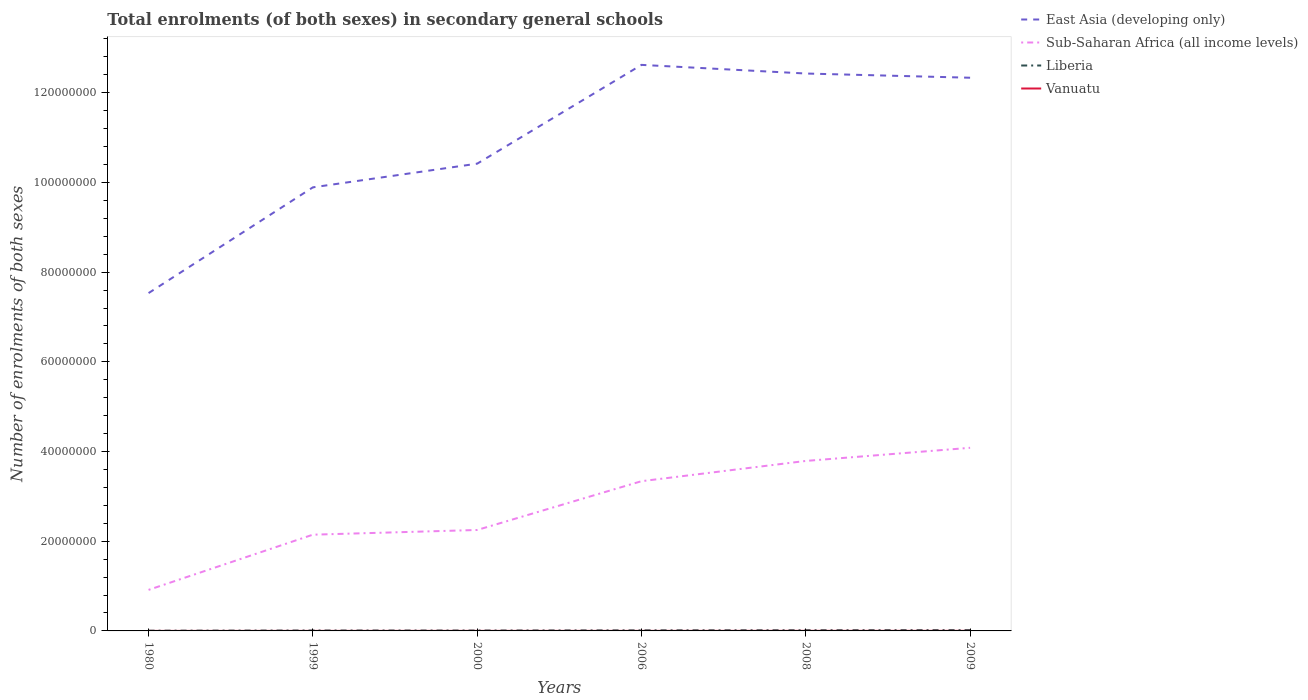Does the line corresponding to East Asia (developing only) intersect with the line corresponding to Liberia?
Your response must be concise. No. Across all years, what is the maximum number of enrolments in secondary schools in Liberia?
Provide a short and direct response. 5.17e+04. What is the total number of enrolments in secondary schools in East Asia (developing only) in the graph?
Keep it short and to the point. -5.28e+06. What is the difference between the highest and the second highest number of enrolments in secondary schools in Liberia?
Ensure brevity in your answer.  1.31e+05. What is the difference between the highest and the lowest number of enrolments in secondary schools in Sub-Saharan Africa (all income levels)?
Provide a short and direct response. 3. Is the number of enrolments in secondary schools in Sub-Saharan Africa (all income levels) strictly greater than the number of enrolments in secondary schools in East Asia (developing only) over the years?
Make the answer very short. Yes. How many lines are there?
Keep it short and to the point. 4. How many years are there in the graph?
Your response must be concise. 6. What is the difference between two consecutive major ticks on the Y-axis?
Ensure brevity in your answer.  2.00e+07. Are the values on the major ticks of Y-axis written in scientific E-notation?
Offer a terse response. No. Does the graph contain grids?
Your answer should be compact. No. How many legend labels are there?
Your response must be concise. 4. What is the title of the graph?
Provide a short and direct response. Total enrolments (of both sexes) in secondary general schools. Does "North America" appear as one of the legend labels in the graph?
Offer a terse response. No. What is the label or title of the X-axis?
Your answer should be compact. Years. What is the label or title of the Y-axis?
Your answer should be compact. Number of enrolments of both sexes. What is the Number of enrolments of both sexes of East Asia (developing only) in 1980?
Give a very brief answer. 7.53e+07. What is the Number of enrolments of both sexes in Sub-Saharan Africa (all income levels) in 1980?
Offer a very short reply. 9.15e+06. What is the Number of enrolments of both sexes of Liberia in 1980?
Your answer should be very brief. 5.17e+04. What is the Number of enrolments of both sexes in Vanuatu in 1980?
Your response must be concise. 1970. What is the Number of enrolments of both sexes in East Asia (developing only) in 1999?
Offer a very short reply. 9.89e+07. What is the Number of enrolments of both sexes in Sub-Saharan Africa (all income levels) in 1999?
Make the answer very short. 2.15e+07. What is the Number of enrolments of both sexes in Liberia in 1999?
Your answer should be compact. 9.41e+04. What is the Number of enrolments of both sexes of Vanuatu in 1999?
Your answer should be very brief. 8056. What is the Number of enrolments of both sexes in East Asia (developing only) in 2000?
Keep it short and to the point. 1.04e+08. What is the Number of enrolments of both sexes of Sub-Saharan Africa (all income levels) in 2000?
Provide a succinct answer. 2.25e+07. What is the Number of enrolments of both sexes of Liberia in 2000?
Your answer should be compact. 9.04e+04. What is the Number of enrolments of both sexes of Vanuatu in 2000?
Your response must be concise. 8580. What is the Number of enrolments of both sexes in East Asia (developing only) in 2006?
Offer a very short reply. 1.26e+08. What is the Number of enrolments of both sexes in Sub-Saharan Africa (all income levels) in 2006?
Your answer should be compact. 3.34e+07. What is the Number of enrolments of both sexes of Liberia in 2006?
Offer a terse response. 1.32e+05. What is the Number of enrolments of both sexes of Vanuatu in 2006?
Ensure brevity in your answer.  9564. What is the Number of enrolments of both sexes in East Asia (developing only) in 2008?
Offer a very short reply. 1.24e+08. What is the Number of enrolments of both sexes in Sub-Saharan Africa (all income levels) in 2008?
Your answer should be compact. 3.79e+07. What is the Number of enrolments of both sexes of Liberia in 2008?
Ensure brevity in your answer.  1.58e+05. What is the Number of enrolments of both sexes of Vanuatu in 2008?
Offer a terse response. 1.67e+04. What is the Number of enrolments of both sexes in East Asia (developing only) in 2009?
Give a very brief answer. 1.23e+08. What is the Number of enrolments of both sexes of Sub-Saharan Africa (all income levels) in 2009?
Ensure brevity in your answer.  4.08e+07. What is the Number of enrolments of both sexes of Liberia in 2009?
Your response must be concise. 1.83e+05. What is the Number of enrolments of both sexes of Vanuatu in 2009?
Provide a succinct answer. 1.79e+04. Across all years, what is the maximum Number of enrolments of both sexes in East Asia (developing only)?
Provide a succinct answer. 1.26e+08. Across all years, what is the maximum Number of enrolments of both sexes of Sub-Saharan Africa (all income levels)?
Your response must be concise. 4.08e+07. Across all years, what is the maximum Number of enrolments of both sexes of Liberia?
Offer a terse response. 1.83e+05. Across all years, what is the maximum Number of enrolments of both sexes of Vanuatu?
Your answer should be very brief. 1.79e+04. Across all years, what is the minimum Number of enrolments of both sexes of East Asia (developing only)?
Ensure brevity in your answer.  7.53e+07. Across all years, what is the minimum Number of enrolments of both sexes in Sub-Saharan Africa (all income levels)?
Make the answer very short. 9.15e+06. Across all years, what is the minimum Number of enrolments of both sexes of Liberia?
Offer a terse response. 5.17e+04. Across all years, what is the minimum Number of enrolments of both sexes in Vanuatu?
Give a very brief answer. 1970. What is the total Number of enrolments of both sexes of East Asia (developing only) in the graph?
Provide a succinct answer. 6.52e+08. What is the total Number of enrolments of both sexes in Sub-Saharan Africa (all income levels) in the graph?
Offer a terse response. 1.65e+08. What is the total Number of enrolments of both sexes of Liberia in the graph?
Your answer should be very brief. 7.10e+05. What is the total Number of enrolments of both sexes in Vanuatu in the graph?
Provide a succinct answer. 6.28e+04. What is the difference between the Number of enrolments of both sexes in East Asia (developing only) in 1980 and that in 1999?
Make the answer very short. -2.36e+07. What is the difference between the Number of enrolments of both sexes of Sub-Saharan Africa (all income levels) in 1980 and that in 1999?
Your response must be concise. -1.23e+07. What is the difference between the Number of enrolments of both sexes in Liberia in 1980 and that in 1999?
Keep it short and to the point. -4.25e+04. What is the difference between the Number of enrolments of both sexes in Vanuatu in 1980 and that in 1999?
Your response must be concise. -6086. What is the difference between the Number of enrolments of both sexes in East Asia (developing only) in 1980 and that in 2000?
Your response must be concise. -2.89e+07. What is the difference between the Number of enrolments of both sexes in Sub-Saharan Africa (all income levels) in 1980 and that in 2000?
Offer a very short reply. -1.34e+07. What is the difference between the Number of enrolments of both sexes of Liberia in 1980 and that in 2000?
Offer a terse response. -3.88e+04. What is the difference between the Number of enrolments of both sexes of Vanuatu in 1980 and that in 2000?
Your answer should be very brief. -6610. What is the difference between the Number of enrolments of both sexes of East Asia (developing only) in 1980 and that in 2006?
Give a very brief answer. -5.09e+07. What is the difference between the Number of enrolments of both sexes of Sub-Saharan Africa (all income levels) in 1980 and that in 2006?
Offer a very short reply. -2.42e+07. What is the difference between the Number of enrolments of both sexes of Liberia in 1980 and that in 2006?
Your answer should be very brief. -8.06e+04. What is the difference between the Number of enrolments of both sexes of Vanuatu in 1980 and that in 2006?
Make the answer very short. -7594. What is the difference between the Number of enrolments of both sexes in East Asia (developing only) in 1980 and that in 2008?
Offer a terse response. -4.90e+07. What is the difference between the Number of enrolments of both sexes of Sub-Saharan Africa (all income levels) in 1980 and that in 2008?
Provide a short and direct response. -2.88e+07. What is the difference between the Number of enrolments of both sexes of Liberia in 1980 and that in 2008?
Keep it short and to the point. -1.07e+05. What is the difference between the Number of enrolments of both sexes of Vanuatu in 1980 and that in 2008?
Your response must be concise. -1.48e+04. What is the difference between the Number of enrolments of both sexes of East Asia (developing only) in 1980 and that in 2009?
Provide a succinct answer. -4.80e+07. What is the difference between the Number of enrolments of both sexes in Sub-Saharan Africa (all income levels) in 1980 and that in 2009?
Provide a short and direct response. -3.17e+07. What is the difference between the Number of enrolments of both sexes in Liberia in 1980 and that in 2009?
Your answer should be compact. -1.31e+05. What is the difference between the Number of enrolments of both sexes of Vanuatu in 1980 and that in 2009?
Offer a terse response. -1.59e+04. What is the difference between the Number of enrolments of both sexes in East Asia (developing only) in 1999 and that in 2000?
Ensure brevity in your answer.  -5.28e+06. What is the difference between the Number of enrolments of both sexes in Sub-Saharan Africa (all income levels) in 1999 and that in 2000?
Your answer should be compact. -1.05e+06. What is the difference between the Number of enrolments of both sexes in Liberia in 1999 and that in 2000?
Your answer should be very brief. 3684. What is the difference between the Number of enrolments of both sexes of Vanuatu in 1999 and that in 2000?
Provide a succinct answer. -524. What is the difference between the Number of enrolments of both sexes of East Asia (developing only) in 1999 and that in 2006?
Ensure brevity in your answer.  -2.73e+07. What is the difference between the Number of enrolments of both sexes of Sub-Saharan Africa (all income levels) in 1999 and that in 2006?
Provide a short and direct response. -1.19e+07. What is the difference between the Number of enrolments of both sexes of Liberia in 1999 and that in 2006?
Your response must be concise. -3.81e+04. What is the difference between the Number of enrolments of both sexes of Vanuatu in 1999 and that in 2006?
Your response must be concise. -1508. What is the difference between the Number of enrolments of both sexes of East Asia (developing only) in 1999 and that in 2008?
Keep it short and to the point. -2.54e+07. What is the difference between the Number of enrolments of both sexes in Sub-Saharan Africa (all income levels) in 1999 and that in 2008?
Your answer should be compact. -1.64e+07. What is the difference between the Number of enrolments of both sexes of Liberia in 1999 and that in 2008?
Provide a short and direct response. -6.41e+04. What is the difference between the Number of enrolments of both sexes in Vanuatu in 1999 and that in 2008?
Ensure brevity in your answer.  -8678. What is the difference between the Number of enrolments of both sexes in East Asia (developing only) in 1999 and that in 2009?
Provide a short and direct response. -2.44e+07. What is the difference between the Number of enrolments of both sexes of Sub-Saharan Africa (all income levels) in 1999 and that in 2009?
Provide a succinct answer. -1.94e+07. What is the difference between the Number of enrolments of both sexes in Liberia in 1999 and that in 2009?
Provide a short and direct response. -8.87e+04. What is the difference between the Number of enrolments of both sexes in Vanuatu in 1999 and that in 2009?
Provide a short and direct response. -9821. What is the difference between the Number of enrolments of both sexes of East Asia (developing only) in 2000 and that in 2006?
Your answer should be very brief. -2.20e+07. What is the difference between the Number of enrolments of both sexes of Sub-Saharan Africa (all income levels) in 2000 and that in 2006?
Provide a short and direct response. -1.09e+07. What is the difference between the Number of enrolments of both sexes in Liberia in 2000 and that in 2006?
Provide a short and direct response. -4.18e+04. What is the difference between the Number of enrolments of both sexes of Vanuatu in 2000 and that in 2006?
Offer a very short reply. -984. What is the difference between the Number of enrolments of both sexes of East Asia (developing only) in 2000 and that in 2008?
Provide a short and direct response. -2.01e+07. What is the difference between the Number of enrolments of both sexes of Sub-Saharan Africa (all income levels) in 2000 and that in 2008?
Give a very brief answer. -1.54e+07. What is the difference between the Number of enrolments of both sexes of Liberia in 2000 and that in 2008?
Offer a terse response. -6.78e+04. What is the difference between the Number of enrolments of both sexes in Vanuatu in 2000 and that in 2008?
Keep it short and to the point. -8154. What is the difference between the Number of enrolments of both sexes in East Asia (developing only) in 2000 and that in 2009?
Provide a short and direct response. -1.92e+07. What is the difference between the Number of enrolments of both sexes of Sub-Saharan Africa (all income levels) in 2000 and that in 2009?
Provide a succinct answer. -1.83e+07. What is the difference between the Number of enrolments of both sexes of Liberia in 2000 and that in 2009?
Make the answer very short. -9.24e+04. What is the difference between the Number of enrolments of both sexes of Vanuatu in 2000 and that in 2009?
Offer a very short reply. -9297. What is the difference between the Number of enrolments of both sexes in East Asia (developing only) in 2006 and that in 2008?
Ensure brevity in your answer.  1.93e+06. What is the difference between the Number of enrolments of both sexes of Sub-Saharan Africa (all income levels) in 2006 and that in 2008?
Give a very brief answer. -4.52e+06. What is the difference between the Number of enrolments of both sexes of Liberia in 2006 and that in 2008?
Provide a short and direct response. -2.60e+04. What is the difference between the Number of enrolments of both sexes in Vanuatu in 2006 and that in 2008?
Your answer should be very brief. -7170. What is the difference between the Number of enrolments of both sexes of East Asia (developing only) in 2006 and that in 2009?
Your answer should be compact. 2.87e+06. What is the difference between the Number of enrolments of both sexes in Sub-Saharan Africa (all income levels) in 2006 and that in 2009?
Give a very brief answer. -7.44e+06. What is the difference between the Number of enrolments of both sexes in Liberia in 2006 and that in 2009?
Provide a short and direct response. -5.06e+04. What is the difference between the Number of enrolments of both sexes of Vanuatu in 2006 and that in 2009?
Ensure brevity in your answer.  -8313. What is the difference between the Number of enrolments of both sexes in East Asia (developing only) in 2008 and that in 2009?
Offer a very short reply. 9.38e+05. What is the difference between the Number of enrolments of both sexes of Sub-Saharan Africa (all income levels) in 2008 and that in 2009?
Ensure brevity in your answer.  -2.93e+06. What is the difference between the Number of enrolments of both sexes of Liberia in 2008 and that in 2009?
Offer a very short reply. -2.46e+04. What is the difference between the Number of enrolments of both sexes in Vanuatu in 2008 and that in 2009?
Give a very brief answer. -1143. What is the difference between the Number of enrolments of both sexes in East Asia (developing only) in 1980 and the Number of enrolments of both sexes in Sub-Saharan Africa (all income levels) in 1999?
Offer a very short reply. 5.39e+07. What is the difference between the Number of enrolments of both sexes in East Asia (developing only) in 1980 and the Number of enrolments of both sexes in Liberia in 1999?
Offer a very short reply. 7.52e+07. What is the difference between the Number of enrolments of both sexes of East Asia (developing only) in 1980 and the Number of enrolments of both sexes of Vanuatu in 1999?
Make the answer very short. 7.53e+07. What is the difference between the Number of enrolments of both sexes of Sub-Saharan Africa (all income levels) in 1980 and the Number of enrolments of both sexes of Liberia in 1999?
Keep it short and to the point. 9.06e+06. What is the difference between the Number of enrolments of both sexes in Sub-Saharan Africa (all income levels) in 1980 and the Number of enrolments of both sexes in Vanuatu in 1999?
Your answer should be very brief. 9.14e+06. What is the difference between the Number of enrolments of both sexes of Liberia in 1980 and the Number of enrolments of both sexes of Vanuatu in 1999?
Offer a terse response. 4.36e+04. What is the difference between the Number of enrolments of both sexes of East Asia (developing only) in 1980 and the Number of enrolments of both sexes of Sub-Saharan Africa (all income levels) in 2000?
Give a very brief answer. 5.28e+07. What is the difference between the Number of enrolments of both sexes in East Asia (developing only) in 1980 and the Number of enrolments of both sexes in Liberia in 2000?
Offer a terse response. 7.52e+07. What is the difference between the Number of enrolments of both sexes in East Asia (developing only) in 1980 and the Number of enrolments of both sexes in Vanuatu in 2000?
Give a very brief answer. 7.53e+07. What is the difference between the Number of enrolments of both sexes in Sub-Saharan Africa (all income levels) in 1980 and the Number of enrolments of both sexes in Liberia in 2000?
Your answer should be compact. 9.06e+06. What is the difference between the Number of enrolments of both sexes of Sub-Saharan Africa (all income levels) in 1980 and the Number of enrolments of both sexes of Vanuatu in 2000?
Provide a short and direct response. 9.14e+06. What is the difference between the Number of enrolments of both sexes of Liberia in 1980 and the Number of enrolments of both sexes of Vanuatu in 2000?
Ensure brevity in your answer.  4.31e+04. What is the difference between the Number of enrolments of both sexes of East Asia (developing only) in 1980 and the Number of enrolments of both sexes of Sub-Saharan Africa (all income levels) in 2006?
Your response must be concise. 4.19e+07. What is the difference between the Number of enrolments of both sexes in East Asia (developing only) in 1980 and the Number of enrolments of both sexes in Liberia in 2006?
Keep it short and to the point. 7.52e+07. What is the difference between the Number of enrolments of both sexes of East Asia (developing only) in 1980 and the Number of enrolments of both sexes of Vanuatu in 2006?
Provide a succinct answer. 7.53e+07. What is the difference between the Number of enrolments of both sexes of Sub-Saharan Africa (all income levels) in 1980 and the Number of enrolments of both sexes of Liberia in 2006?
Offer a terse response. 9.02e+06. What is the difference between the Number of enrolments of both sexes of Sub-Saharan Africa (all income levels) in 1980 and the Number of enrolments of both sexes of Vanuatu in 2006?
Your response must be concise. 9.14e+06. What is the difference between the Number of enrolments of both sexes of Liberia in 1980 and the Number of enrolments of both sexes of Vanuatu in 2006?
Ensure brevity in your answer.  4.21e+04. What is the difference between the Number of enrolments of both sexes in East Asia (developing only) in 1980 and the Number of enrolments of both sexes in Sub-Saharan Africa (all income levels) in 2008?
Your response must be concise. 3.74e+07. What is the difference between the Number of enrolments of both sexes in East Asia (developing only) in 1980 and the Number of enrolments of both sexes in Liberia in 2008?
Give a very brief answer. 7.52e+07. What is the difference between the Number of enrolments of both sexes of East Asia (developing only) in 1980 and the Number of enrolments of both sexes of Vanuatu in 2008?
Make the answer very short. 7.53e+07. What is the difference between the Number of enrolments of both sexes of Sub-Saharan Africa (all income levels) in 1980 and the Number of enrolments of both sexes of Liberia in 2008?
Your response must be concise. 8.99e+06. What is the difference between the Number of enrolments of both sexes of Sub-Saharan Africa (all income levels) in 1980 and the Number of enrolments of both sexes of Vanuatu in 2008?
Give a very brief answer. 9.13e+06. What is the difference between the Number of enrolments of both sexes of Liberia in 1980 and the Number of enrolments of both sexes of Vanuatu in 2008?
Your response must be concise. 3.49e+04. What is the difference between the Number of enrolments of both sexes of East Asia (developing only) in 1980 and the Number of enrolments of both sexes of Sub-Saharan Africa (all income levels) in 2009?
Offer a terse response. 3.45e+07. What is the difference between the Number of enrolments of both sexes of East Asia (developing only) in 1980 and the Number of enrolments of both sexes of Liberia in 2009?
Offer a very short reply. 7.51e+07. What is the difference between the Number of enrolments of both sexes in East Asia (developing only) in 1980 and the Number of enrolments of both sexes in Vanuatu in 2009?
Make the answer very short. 7.53e+07. What is the difference between the Number of enrolments of both sexes in Sub-Saharan Africa (all income levels) in 1980 and the Number of enrolments of both sexes in Liberia in 2009?
Provide a succinct answer. 8.97e+06. What is the difference between the Number of enrolments of both sexes in Sub-Saharan Africa (all income levels) in 1980 and the Number of enrolments of both sexes in Vanuatu in 2009?
Keep it short and to the point. 9.13e+06. What is the difference between the Number of enrolments of both sexes of Liberia in 1980 and the Number of enrolments of both sexes of Vanuatu in 2009?
Keep it short and to the point. 3.38e+04. What is the difference between the Number of enrolments of both sexes in East Asia (developing only) in 1999 and the Number of enrolments of both sexes in Sub-Saharan Africa (all income levels) in 2000?
Offer a terse response. 7.64e+07. What is the difference between the Number of enrolments of both sexes of East Asia (developing only) in 1999 and the Number of enrolments of both sexes of Liberia in 2000?
Provide a short and direct response. 9.88e+07. What is the difference between the Number of enrolments of both sexes of East Asia (developing only) in 1999 and the Number of enrolments of both sexes of Vanuatu in 2000?
Offer a very short reply. 9.89e+07. What is the difference between the Number of enrolments of both sexes in Sub-Saharan Africa (all income levels) in 1999 and the Number of enrolments of both sexes in Liberia in 2000?
Your response must be concise. 2.14e+07. What is the difference between the Number of enrolments of both sexes in Sub-Saharan Africa (all income levels) in 1999 and the Number of enrolments of both sexes in Vanuatu in 2000?
Offer a very short reply. 2.15e+07. What is the difference between the Number of enrolments of both sexes of Liberia in 1999 and the Number of enrolments of both sexes of Vanuatu in 2000?
Your answer should be very brief. 8.55e+04. What is the difference between the Number of enrolments of both sexes in East Asia (developing only) in 1999 and the Number of enrolments of both sexes in Sub-Saharan Africa (all income levels) in 2006?
Offer a terse response. 6.55e+07. What is the difference between the Number of enrolments of both sexes in East Asia (developing only) in 1999 and the Number of enrolments of both sexes in Liberia in 2006?
Make the answer very short. 9.88e+07. What is the difference between the Number of enrolments of both sexes of East Asia (developing only) in 1999 and the Number of enrolments of both sexes of Vanuatu in 2006?
Offer a terse response. 9.89e+07. What is the difference between the Number of enrolments of both sexes of Sub-Saharan Africa (all income levels) in 1999 and the Number of enrolments of both sexes of Liberia in 2006?
Provide a short and direct response. 2.13e+07. What is the difference between the Number of enrolments of both sexes of Sub-Saharan Africa (all income levels) in 1999 and the Number of enrolments of both sexes of Vanuatu in 2006?
Give a very brief answer. 2.14e+07. What is the difference between the Number of enrolments of both sexes in Liberia in 1999 and the Number of enrolments of both sexes in Vanuatu in 2006?
Keep it short and to the point. 8.46e+04. What is the difference between the Number of enrolments of both sexes in East Asia (developing only) in 1999 and the Number of enrolments of both sexes in Sub-Saharan Africa (all income levels) in 2008?
Give a very brief answer. 6.10e+07. What is the difference between the Number of enrolments of both sexes in East Asia (developing only) in 1999 and the Number of enrolments of both sexes in Liberia in 2008?
Ensure brevity in your answer.  9.87e+07. What is the difference between the Number of enrolments of both sexes of East Asia (developing only) in 1999 and the Number of enrolments of both sexes of Vanuatu in 2008?
Give a very brief answer. 9.89e+07. What is the difference between the Number of enrolments of both sexes in Sub-Saharan Africa (all income levels) in 1999 and the Number of enrolments of both sexes in Liberia in 2008?
Your answer should be compact. 2.13e+07. What is the difference between the Number of enrolments of both sexes of Sub-Saharan Africa (all income levels) in 1999 and the Number of enrolments of both sexes of Vanuatu in 2008?
Ensure brevity in your answer.  2.14e+07. What is the difference between the Number of enrolments of both sexes in Liberia in 1999 and the Number of enrolments of both sexes in Vanuatu in 2008?
Your response must be concise. 7.74e+04. What is the difference between the Number of enrolments of both sexes in East Asia (developing only) in 1999 and the Number of enrolments of both sexes in Sub-Saharan Africa (all income levels) in 2009?
Make the answer very short. 5.81e+07. What is the difference between the Number of enrolments of both sexes of East Asia (developing only) in 1999 and the Number of enrolments of both sexes of Liberia in 2009?
Provide a short and direct response. 9.87e+07. What is the difference between the Number of enrolments of both sexes of East Asia (developing only) in 1999 and the Number of enrolments of both sexes of Vanuatu in 2009?
Your answer should be compact. 9.89e+07. What is the difference between the Number of enrolments of both sexes of Sub-Saharan Africa (all income levels) in 1999 and the Number of enrolments of both sexes of Liberia in 2009?
Ensure brevity in your answer.  2.13e+07. What is the difference between the Number of enrolments of both sexes in Sub-Saharan Africa (all income levels) in 1999 and the Number of enrolments of both sexes in Vanuatu in 2009?
Your response must be concise. 2.14e+07. What is the difference between the Number of enrolments of both sexes in Liberia in 1999 and the Number of enrolments of both sexes in Vanuatu in 2009?
Keep it short and to the point. 7.62e+04. What is the difference between the Number of enrolments of both sexes of East Asia (developing only) in 2000 and the Number of enrolments of both sexes of Sub-Saharan Africa (all income levels) in 2006?
Ensure brevity in your answer.  7.08e+07. What is the difference between the Number of enrolments of both sexes in East Asia (developing only) in 2000 and the Number of enrolments of both sexes in Liberia in 2006?
Offer a very short reply. 1.04e+08. What is the difference between the Number of enrolments of both sexes in East Asia (developing only) in 2000 and the Number of enrolments of both sexes in Vanuatu in 2006?
Ensure brevity in your answer.  1.04e+08. What is the difference between the Number of enrolments of both sexes in Sub-Saharan Africa (all income levels) in 2000 and the Number of enrolments of both sexes in Liberia in 2006?
Offer a very short reply. 2.24e+07. What is the difference between the Number of enrolments of both sexes of Sub-Saharan Africa (all income levels) in 2000 and the Number of enrolments of both sexes of Vanuatu in 2006?
Provide a succinct answer. 2.25e+07. What is the difference between the Number of enrolments of both sexes in Liberia in 2000 and the Number of enrolments of both sexes in Vanuatu in 2006?
Your response must be concise. 8.09e+04. What is the difference between the Number of enrolments of both sexes in East Asia (developing only) in 2000 and the Number of enrolments of both sexes in Sub-Saharan Africa (all income levels) in 2008?
Provide a short and direct response. 6.63e+07. What is the difference between the Number of enrolments of both sexes in East Asia (developing only) in 2000 and the Number of enrolments of both sexes in Liberia in 2008?
Your answer should be compact. 1.04e+08. What is the difference between the Number of enrolments of both sexes in East Asia (developing only) in 2000 and the Number of enrolments of both sexes in Vanuatu in 2008?
Give a very brief answer. 1.04e+08. What is the difference between the Number of enrolments of both sexes in Sub-Saharan Africa (all income levels) in 2000 and the Number of enrolments of both sexes in Liberia in 2008?
Provide a short and direct response. 2.23e+07. What is the difference between the Number of enrolments of both sexes of Sub-Saharan Africa (all income levels) in 2000 and the Number of enrolments of both sexes of Vanuatu in 2008?
Provide a succinct answer. 2.25e+07. What is the difference between the Number of enrolments of both sexes in Liberia in 2000 and the Number of enrolments of both sexes in Vanuatu in 2008?
Your answer should be compact. 7.37e+04. What is the difference between the Number of enrolments of both sexes of East Asia (developing only) in 2000 and the Number of enrolments of both sexes of Sub-Saharan Africa (all income levels) in 2009?
Provide a succinct answer. 6.34e+07. What is the difference between the Number of enrolments of both sexes of East Asia (developing only) in 2000 and the Number of enrolments of both sexes of Liberia in 2009?
Your answer should be compact. 1.04e+08. What is the difference between the Number of enrolments of both sexes of East Asia (developing only) in 2000 and the Number of enrolments of both sexes of Vanuatu in 2009?
Your answer should be compact. 1.04e+08. What is the difference between the Number of enrolments of both sexes in Sub-Saharan Africa (all income levels) in 2000 and the Number of enrolments of both sexes in Liberia in 2009?
Give a very brief answer. 2.23e+07. What is the difference between the Number of enrolments of both sexes of Sub-Saharan Africa (all income levels) in 2000 and the Number of enrolments of both sexes of Vanuatu in 2009?
Keep it short and to the point. 2.25e+07. What is the difference between the Number of enrolments of both sexes of Liberia in 2000 and the Number of enrolments of both sexes of Vanuatu in 2009?
Your answer should be compact. 7.26e+04. What is the difference between the Number of enrolments of both sexes of East Asia (developing only) in 2006 and the Number of enrolments of both sexes of Sub-Saharan Africa (all income levels) in 2008?
Offer a terse response. 8.83e+07. What is the difference between the Number of enrolments of both sexes in East Asia (developing only) in 2006 and the Number of enrolments of both sexes in Liberia in 2008?
Your answer should be very brief. 1.26e+08. What is the difference between the Number of enrolments of both sexes in East Asia (developing only) in 2006 and the Number of enrolments of both sexes in Vanuatu in 2008?
Keep it short and to the point. 1.26e+08. What is the difference between the Number of enrolments of both sexes of Sub-Saharan Africa (all income levels) in 2006 and the Number of enrolments of both sexes of Liberia in 2008?
Offer a terse response. 3.32e+07. What is the difference between the Number of enrolments of both sexes of Sub-Saharan Africa (all income levels) in 2006 and the Number of enrolments of both sexes of Vanuatu in 2008?
Provide a succinct answer. 3.34e+07. What is the difference between the Number of enrolments of both sexes in Liberia in 2006 and the Number of enrolments of both sexes in Vanuatu in 2008?
Keep it short and to the point. 1.15e+05. What is the difference between the Number of enrolments of both sexes in East Asia (developing only) in 2006 and the Number of enrolments of both sexes in Sub-Saharan Africa (all income levels) in 2009?
Give a very brief answer. 8.54e+07. What is the difference between the Number of enrolments of both sexes in East Asia (developing only) in 2006 and the Number of enrolments of both sexes in Liberia in 2009?
Make the answer very short. 1.26e+08. What is the difference between the Number of enrolments of both sexes of East Asia (developing only) in 2006 and the Number of enrolments of both sexes of Vanuatu in 2009?
Provide a short and direct response. 1.26e+08. What is the difference between the Number of enrolments of both sexes of Sub-Saharan Africa (all income levels) in 2006 and the Number of enrolments of both sexes of Liberia in 2009?
Offer a terse response. 3.32e+07. What is the difference between the Number of enrolments of both sexes in Sub-Saharan Africa (all income levels) in 2006 and the Number of enrolments of both sexes in Vanuatu in 2009?
Your answer should be very brief. 3.34e+07. What is the difference between the Number of enrolments of both sexes in Liberia in 2006 and the Number of enrolments of both sexes in Vanuatu in 2009?
Your answer should be very brief. 1.14e+05. What is the difference between the Number of enrolments of both sexes of East Asia (developing only) in 2008 and the Number of enrolments of both sexes of Sub-Saharan Africa (all income levels) in 2009?
Keep it short and to the point. 8.35e+07. What is the difference between the Number of enrolments of both sexes of East Asia (developing only) in 2008 and the Number of enrolments of both sexes of Liberia in 2009?
Give a very brief answer. 1.24e+08. What is the difference between the Number of enrolments of both sexes of East Asia (developing only) in 2008 and the Number of enrolments of both sexes of Vanuatu in 2009?
Offer a very short reply. 1.24e+08. What is the difference between the Number of enrolments of both sexes of Sub-Saharan Africa (all income levels) in 2008 and the Number of enrolments of both sexes of Liberia in 2009?
Give a very brief answer. 3.77e+07. What is the difference between the Number of enrolments of both sexes of Sub-Saharan Africa (all income levels) in 2008 and the Number of enrolments of both sexes of Vanuatu in 2009?
Provide a succinct answer. 3.79e+07. What is the difference between the Number of enrolments of both sexes in Liberia in 2008 and the Number of enrolments of both sexes in Vanuatu in 2009?
Provide a short and direct response. 1.40e+05. What is the average Number of enrolments of both sexes of East Asia (developing only) per year?
Your answer should be very brief. 1.09e+08. What is the average Number of enrolments of both sexes of Sub-Saharan Africa (all income levels) per year?
Your answer should be compact. 2.75e+07. What is the average Number of enrolments of both sexes in Liberia per year?
Keep it short and to the point. 1.18e+05. What is the average Number of enrolments of both sexes of Vanuatu per year?
Give a very brief answer. 1.05e+04. In the year 1980, what is the difference between the Number of enrolments of both sexes of East Asia (developing only) and Number of enrolments of both sexes of Sub-Saharan Africa (all income levels)?
Offer a terse response. 6.62e+07. In the year 1980, what is the difference between the Number of enrolments of both sexes in East Asia (developing only) and Number of enrolments of both sexes in Liberia?
Offer a terse response. 7.53e+07. In the year 1980, what is the difference between the Number of enrolments of both sexes of East Asia (developing only) and Number of enrolments of both sexes of Vanuatu?
Your answer should be very brief. 7.53e+07. In the year 1980, what is the difference between the Number of enrolments of both sexes in Sub-Saharan Africa (all income levels) and Number of enrolments of both sexes in Liberia?
Offer a terse response. 9.10e+06. In the year 1980, what is the difference between the Number of enrolments of both sexes of Sub-Saharan Africa (all income levels) and Number of enrolments of both sexes of Vanuatu?
Your response must be concise. 9.15e+06. In the year 1980, what is the difference between the Number of enrolments of both sexes in Liberia and Number of enrolments of both sexes in Vanuatu?
Offer a very short reply. 4.97e+04. In the year 1999, what is the difference between the Number of enrolments of both sexes of East Asia (developing only) and Number of enrolments of both sexes of Sub-Saharan Africa (all income levels)?
Give a very brief answer. 7.74e+07. In the year 1999, what is the difference between the Number of enrolments of both sexes in East Asia (developing only) and Number of enrolments of both sexes in Liberia?
Offer a terse response. 9.88e+07. In the year 1999, what is the difference between the Number of enrolments of both sexes in East Asia (developing only) and Number of enrolments of both sexes in Vanuatu?
Provide a short and direct response. 9.89e+07. In the year 1999, what is the difference between the Number of enrolments of both sexes in Sub-Saharan Africa (all income levels) and Number of enrolments of both sexes in Liberia?
Offer a very short reply. 2.14e+07. In the year 1999, what is the difference between the Number of enrolments of both sexes in Sub-Saharan Africa (all income levels) and Number of enrolments of both sexes in Vanuatu?
Keep it short and to the point. 2.15e+07. In the year 1999, what is the difference between the Number of enrolments of both sexes of Liberia and Number of enrolments of both sexes of Vanuatu?
Offer a very short reply. 8.61e+04. In the year 2000, what is the difference between the Number of enrolments of both sexes of East Asia (developing only) and Number of enrolments of both sexes of Sub-Saharan Africa (all income levels)?
Provide a succinct answer. 8.17e+07. In the year 2000, what is the difference between the Number of enrolments of both sexes in East Asia (developing only) and Number of enrolments of both sexes in Liberia?
Your answer should be compact. 1.04e+08. In the year 2000, what is the difference between the Number of enrolments of both sexes in East Asia (developing only) and Number of enrolments of both sexes in Vanuatu?
Offer a very short reply. 1.04e+08. In the year 2000, what is the difference between the Number of enrolments of both sexes in Sub-Saharan Africa (all income levels) and Number of enrolments of both sexes in Liberia?
Keep it short and to the point. 2.24e+07. In the year 2000, what is the difference between the Number of enrolments of both sexes of Sub-Saharan Africa (all income levels) and Number of enrolments of both sexes of Vanuatu?
Your response must be concise. 2.25e+07. In the year 2000, what is the difference between the Number of enrolments of both sexes in Liberia and Number of enrolments of both sexes in Vanuatu?
Offer a terse response. 8.19e+04. In the year 2006, what is the difference between the Number of enrolments of both sexes of East Asia (developing only) and Number of enrolments of both sexes of Sub-Saharan Africa (all income levels)?
Offer a terse response. 9.28e+07. In the year 2006, what is the difference between the Number of enrolments of both sexes in East Asia (developing only) and Number of enrolments of both sexes in Liberia?
Your answer should be compact. 1.26e+08. In the year 2006, what is the difference between the Number of enrolments of both sexes of East Asia (developing only) and Number of enrolments of both sexes of Vanuatu?
Give a very brief answer. 1.26e+08. In the year 2006, what is the difference between the Number of enrolments of both sexes of Sub-Saharan Africa (all income levels) and Number of enrolments of both sexes of Liberia?
Provide a succinct answer. 3.33e+07. In the year 2006, what is the difference between the Number of enrolments of both sexes in Sub-Saharan Africa (all income levels) and Number of enrolments of both sexes in Vanuatu?
Make the answer very short. 3.34e+07. In the year 2006, what is the difference between the Number of enrolments of both sexes in Liberia and Number of enrolments of both sexes in Vanuatu?
Your response must be concise. 1.23e+05. In the year 2008, what is the difference between the Number of enrolments of both sexes in East Asia (developing only) and Number of enrolments of both sexes in Sub-Saharan Africa (all income levels)?
Your answer should be compact. 8.64e+07. In the year 2008, what is the difference between the Number of enrolments of both sexes in East Asia (developing only) and Number of enrolments of both sexes in Liberia?
Ensure brevity in your answer.  1.24e+08. In the year 2008, what is the difference between the Number of enrolments of both sexes of East Asia (developing only) and Number of enrolments of both sexes of Vanuatu?
Give a very brief answer. 1.24e+08. In the year 2008, what is the difference between the Number of enrolments of both sexes in Sub-Saharan Africa (all income levels) and Number of enrolments of both sexes in Liberia?
Offer a very short reply. 3.77e+07. In the year 2008, what is the difference between the Number of enrolments of both sexes of Sub-Saharan Africa (all income levels) and Number of enrolments of both sexes of Vanuatu?
Provide a short and direct response. 3.79e+07. In the year 2008, what is the difference between the Number of enrolments of both sexes of Liberia and Number of enrolments of both sexes of Vanuatu?
Your response must be concise. 1.42e+05. In the year 2009, what is the difference between the Number of enrolments of both sexes of East Asia (developing only) and Number of enrolments of both sexes of Sub-Saharan Africa (all income levels)?
Make the answer very short. 8.25e+07. In the year 2009, what is the difference between the Number of enrolments of both sexes of East Asia (developing only) and Number of enrolments of both sexes of Liberia?
Offer a terse response. 1.23e+08. In the year 2009, what is the difference between the Number of enrolments of both sexes in East Asia (developing only) and Number of enrolments of both sexes in Vanuatu?
Provide a succinct answer. 1.23e+08. In the year 2009, what is the difference between the Number of enrolments of both sexes in Sub-Saharan Africa (all income levels) and Number of enrolments of both sexes in Liberia?
Your answer should be compact. 4.06e+07. In the year 2009, what is the difference between the Number of enrolments of both sexes of Sub-Saharan Africa (all income levels) and Number of enrolments of both sexes of Vanuatu?
Offer a very short reply. 4.08e+07. In the year 2009, what is the difference between the Number of enrolments of both sexes in Liberia and Number of enrolments of both sexes in Vanuatu?
Your answer should be very brief. 1.65e+05. What is the ratio of the Number of enrolments of both sexes in East Asia (developing only) in 1980 to that in 1999?
Your response must be concise. 0.76. What is the ratio of the Number of enrolments of both sexes in Sub-Saharan Africa (all income levels) in 1980 to that in 1999?
Give a very brief answer. 0.43. What is the ratio of the Number of enrolments of both sexes in Liberia in 1980 to that in 1999?
Your answer should be very brief. 0.55. What is the ratio of the Number of enrolments of both sexes of Vanuatu in 1980 to that in 1999?
Your answer should be very brief. 0.24. What is the ratio of the Number of enrolments of both sexes of East Asia (developing only) in 1980 to that in 2000?
Your answer should be compact. 0.72. What is the ratio of the Number of enrolments of both sexes in Sub-Saharan Africa (all income levels) in 1980 to that in 2000?
Give a very brief answer. 0.41. What is the ratio of the Number of enrolments of both sexes of Liberia in 1980 to that in 2000?
Keep it short and to the point. 0.57. What is the ratio of the Number of enrolments of both sexes of Vanuatu in 1980 to that in 2000?
Your response must be concise. 0.23. What is the ratio of the Number of enrolments of both sexes of East Asia (developing only) in 1980 to that in 2006?
Make the answer very short. 0.6. What is the ratio of the Number of enrolments of both sexes of Sub-Saharan Africa (all income levels) in 1980 to that in 2006?
Your answer should be compact. 0.27. What is the ratio of the Number of enrolments of both sexes of Liberia in 1980 to that in 2006?
Keep it short and to the point. 0.39. What is the ratio of the Number of enrolments of both sexes in Vanuatu in 1980 to that in 2006?
Offer a very short reply. 0.21. What is the ratio of the Number of enrolments of both sexes in East Asia (developing only) in 1980 to that in 2008?
Provide a short and direct response. 0.61. What is the ratio of the Number of enrolments of both sexes of Sub-Saharan Africa (all income levels) in 1980 to that in 2008?
Make the answer very short. 0.24. What is the ratio of the Number of enrolments of both sexes of Liberia in 1980 to that in 2008?
Your response must be concise. 0.33. What is the ratio of the Number of enrolments of both sexes in Vanuatu in 1980 to that in 2008?
Give a very brief answer. 0.12. What is the ratio of the Number of enrolments of both sexes of East Asia (developing only) in 1980 to that in 2009?
Give a very brief answer. 0.61. What is the ratio of the Number of enrolments of both sexes of Sub-Saharan Africa (all income levels) in 1980 to that in 2009?
Your answer should be very brief. 0.22. What is the ratio of the Number of enrolments of both sexes in Liberia in 1980 to that in 2009?
Provide a succinct answer. 0.28. What is the ratio of the Number of enrolments of both sexes in Vanuatu in 1980 to that in 2009?
Your answer should be compact. 0.11. What is the ratio of the Number of enrolments of both sexes in East Asia (developing only) in 1999 to that in 2000?
Provide a succinct answer. 0.95. What is the ratio of the Number of enrolments of both sexes of Sub-Saharan Africa (all income levels) in 1999 to that in 2000?
Offer a terse response. 0.95. What is the ratio of the Number of enrolments of both sexes in Liberia in 1999 to that in 2000?
Keep it short and to the point. 1.04. What is the ratio of the Number of enrolments of both sexes in Vanuatu in 1999 to that in 2000?
Your answer should be very brief. 0.94. What is the ratio of the Number of enrolments of both sexes of East Asia (developing only) in 1999 to that in 2006?
Provide a succinct answer. 0.78. What is the ratio of the Number of enrolments of both sexes in Sub-Saharan Africa (all income levels) in 1999 to that in 2006?
Make the answer very short. 0.64. What is the ratio of the Number of enrolments of both sexes in Liberia in 1999 to that in 2006?
Provide a succinct answer. 0.71. What is the ratio of the Number of enrolments of both sexes in Vanuatu in 1999 to that in 2006?
Ensure brevity in your answer.  0.84. What is the ratio of the Number of enrolments of both sexes in East Asia (developing only) in 1999 to that in 2008?
Offer a terse response. 0.8. What is the ratio of the Number of enrolments of both sexes of Sub-Saharan Africa (all income levels) in 1999 to that in 2008?
Keep it short and to the point. 0.57. What is the ratio of the Number of enrolments of both sexes of Liberia in 1999 to that in 2008?
Ensure brevity in your answer.  0.59. What is the ratio of the Number of enrolments of both sexes in Vanuatu in 1999 to that in 2008?
Your response must be concise. 0.48. What is the ratio of the Number of enrolments of both sexes of East Asia (developing only) in 1999 to that in 2009?
Offer a very short reply. 0.8. What is the ratio of the Number of enrolments of both sexes in Sub-Saharan Africa (all income levels) in 1999 to that in 2009?
Provide a succinct answer. 0.53. What is the ratio of the Number of enrolments of both sexes of Liberia in 1999 to that in 2009?
Provide a short and direct response. 0.51. What is the ratio of the Number of enrolments of both sexes of Vanuatu in 1999 to that in 2009?
Provide a short and direct response. 0.45. What is the ratio of the Number of enrolments of both sexes of East Asia (developing only) in 2000 to that in 2006?
Your answer should be very brief. 0.83. What is the ratio of the Number of enrolments of both sexes in Sub-Saharan Africa (all income levels) in 2000 to that in 2006?
Ensure brevity in your answer.  0.67. What is the ratio of the Number of enrolments of both sexes in Liberia in 2000 to that in 2006?
Your response must be concise. 0.68. What is the ratio of the Number of enrolments of both sexes in Vanuatu in 2000 to that in 2006?
Provide a short and direct response. 0.9. What is the ratio of the Number of enrolments of both sexes of East Asia (developing only) in 2000 to that in 2008?
Keep it short and to the point. 0.84. What is the ratio of the Number of enrolments of both sexes of Sub-Saharan Africa (all income levels) in 2000 to that in 2008?
Your answer should be very brief. 0.59. What is the ratio of the Number of enrolments of both sexes in Liberia in 2000 to that in 2008?
Provide a succinct answer. 0.57. What is the ratio of the Number of enrolments of both sexes in Vanuatu in 2000 to that in 2008?
Ensure brevity in your answer.  0.51. What is the ratio of the Number of enrolments of both sexes in East Asia (developing only) in 2000 to that in 2009?
Give a very brief answer. 0.84. What is the ratio of the Number of enrolments of both sexes in Sub-Saharan Africa (all income levels) in 2000 to that in 2009?
Offer a terse response. 0.55. What is the ratio of the Number of enrolments of both sexes of Liberia in 2000 to that in 2009?
Keep it short and to the point. 0.49. What is the ratio of the Number of enrolments of both sexes of Vanuatu in 2000 to that in 2009?
Your response must be concise. 0.48. What is the ratio of the Number of enrolments of both sexes of East Asia (developing only) in 2006 to that in 2008?
Your answer should be very brief. 1.02. What is the ratio of the Number of enrolments of both sexes of Sub-Saharan Africa (all income levels) in 2006 to that in 2008?
Give a very brief answer. 0.88. What is the ratio of the Number of enrolments of both sexes of Liberia in 2006 to that in 2008?
Ensure brevity in your answer.  0.84. What is the ratio of the Number of enrolments of both sexes in Vanuatu in 2006 to that in 2008?
Give a very brief answer. 0.57. What is the ratio of the Number of enrolments of both sexes of East Asia (developing only) in 2006 to that in 2009?
Your answer should be very brief. 1.02. What is the ratio of the Number of enrolments of both sexes of Sub-Saharan Africa (all income levels) in 2006 to that in 2009?
Your answer should be very brief. 0.82. What is the ratio of the Number of enrolments of both sexes of Liberia in 2006 to that in 2009?
Your answer should be very brief. 0.72. What is the ratio of the Number of enrolments of both sexes of Vanuatu in 2006 to that in 2009?
Make the answer very short. 0.54. What is the ratio of the Number of enrolments of both sexes in East Asia (developing only) in 2008 to that in 2009?
Give a very brief answer. 1.01. What is the ratio of the Number of enrolments of both sexes in Sub-Saharan Africa (all income levels) in 2008 to that in 2009?
Make the answer very short. 0.93. What is the ratio of the Number of enrolments of both sexes in Liberia in 2008 to that in 2009?
Your answer should be very brief. 0.87. What is the ratio of the Number of enrolments of both sexes in Vanuatu in 2008 to that in 2009?
Keep it short and to the point. 0.94. What is the difference between the highest and the second highest Number of enrolments of both sexes in East Asia (developing only)?
Offer a terse response. 1.93e+06. What is the difference between the highest and the second highest Number of enrolments of both sexes of Sub-Saharan Africa (all income levels)?
Ensure brevity in your answer.  2.93e+06. What is the difference between the highest and the second highest Number of enrolments of both sexes of Liberia?
Your answer should be very brief. 2.46e+04. What is the difference between the highest and the second highest Number of enrolments of both sexes in Vanuatu?
Offer a terse response. 1143. What is the difference between the highest and the lowest Number of enrolments of both sexes of East Asia (developing only)?
Give a very brief answer. 5.09e+07. What is the difference between the highest and the lowest Number of enrolments of both sexes in Sub-Saharan Africa (all income levels)?
Provide a short and direct response. 3.17e+07. What is the difference between the highest and the lowest Number of enrolments of both sexes in Liberia?
Your answer should be very brief. 1.31e+05. What is the difference between the highest and the lowest Number of enrolments of both sexes of Vanuatu?
Give a very brief answer. 1.59e+04. 